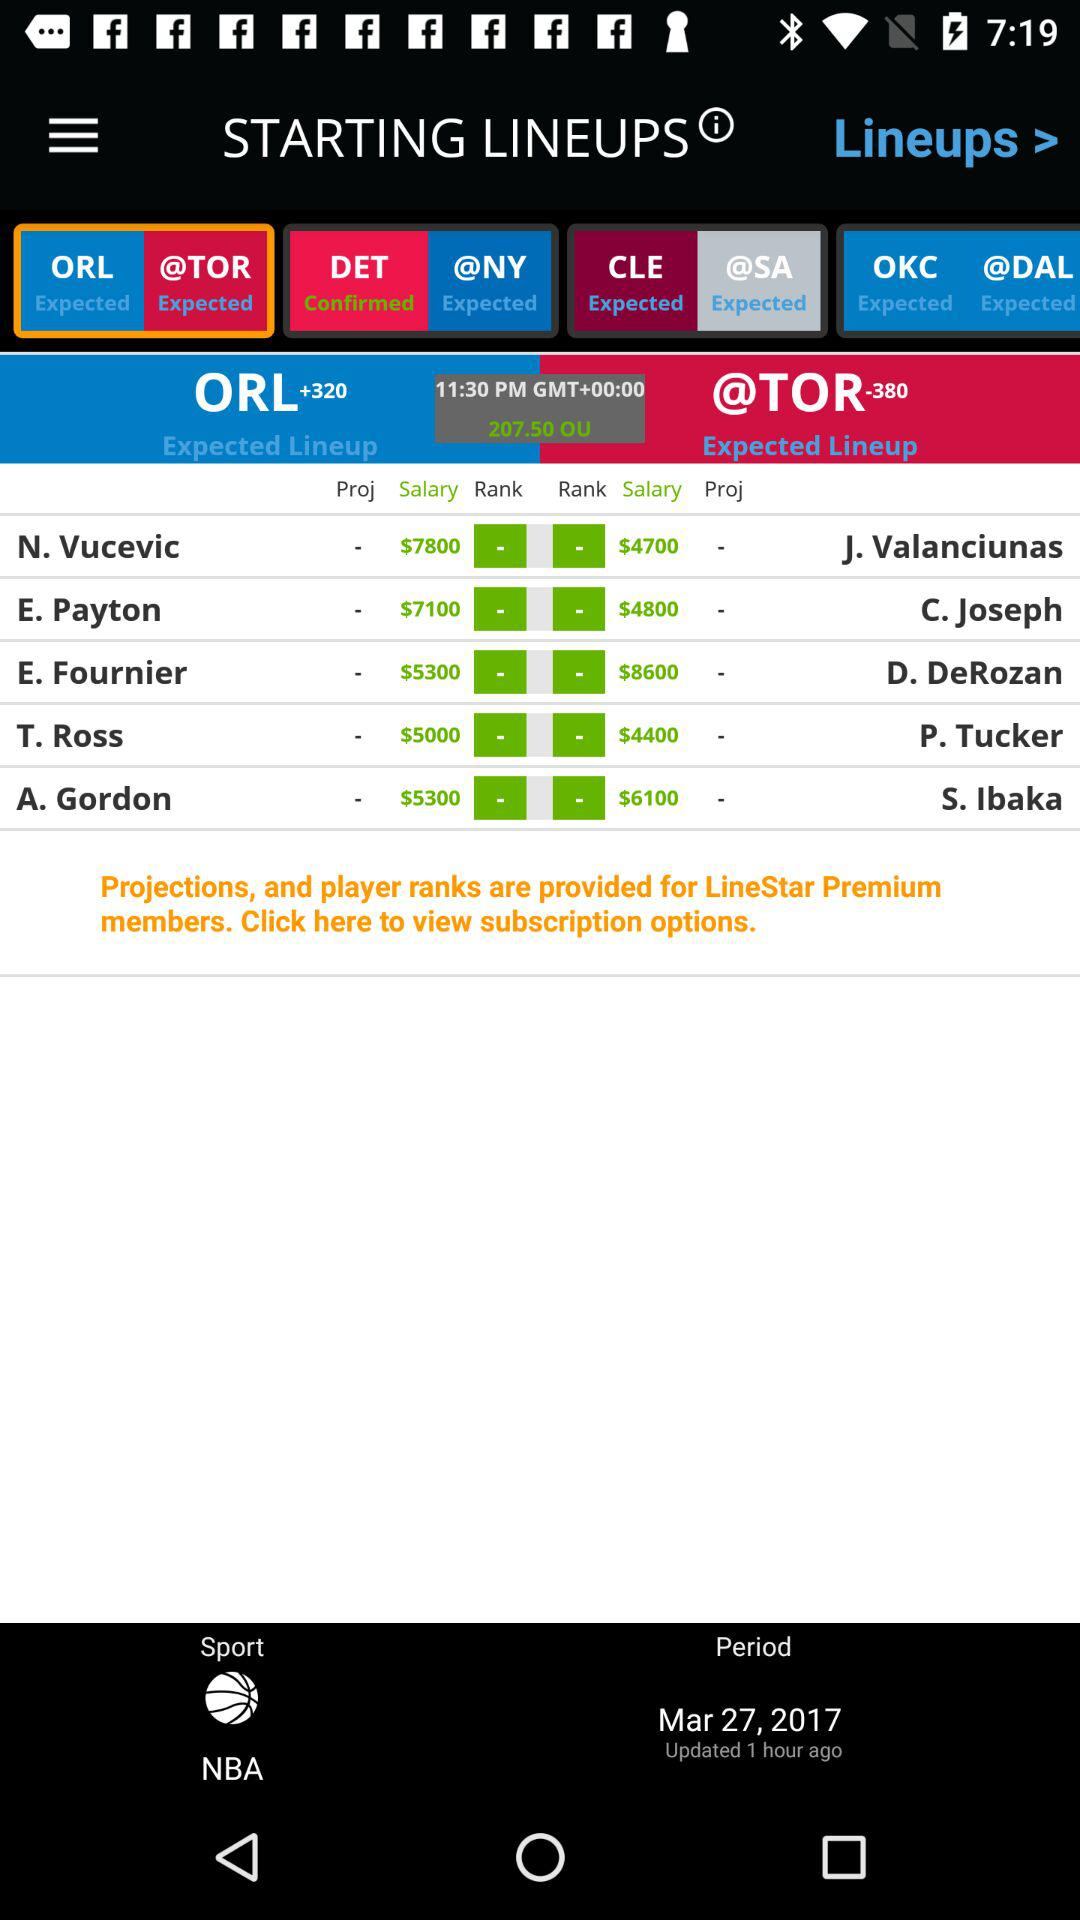What is the sport name? The sport name is "NBA". 